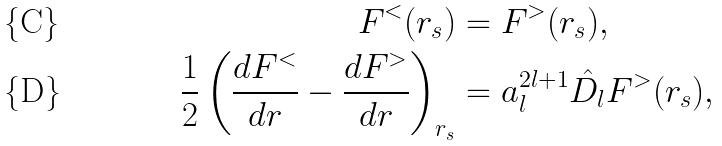<formula> <loc_0><loc_0><loc_500><loc_500>F ^ { < } ( r _ { s } ) & = F ^ { > } ( r _ { s } ) , \\ \frac { 1 } { 2 } \left ( \frac { d F ^ { < } } { d r } - \frac { d F ^ { > } } { d r } \right ) _ { r _ { s } } & = a _ { l } ^ { 2 l + 1 } \hat { D _ { l } } F ^ { > } ( r _ { s } ) ,</formula> 